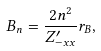Convert formula to latex. <formula><loc_0><loc_0><loc_500><loc_500>B _ { n } = \frac { 2 n ^ { 2 } } { Z _ { - x x } ^ { \prime } } r _ { B } ,</formula> 